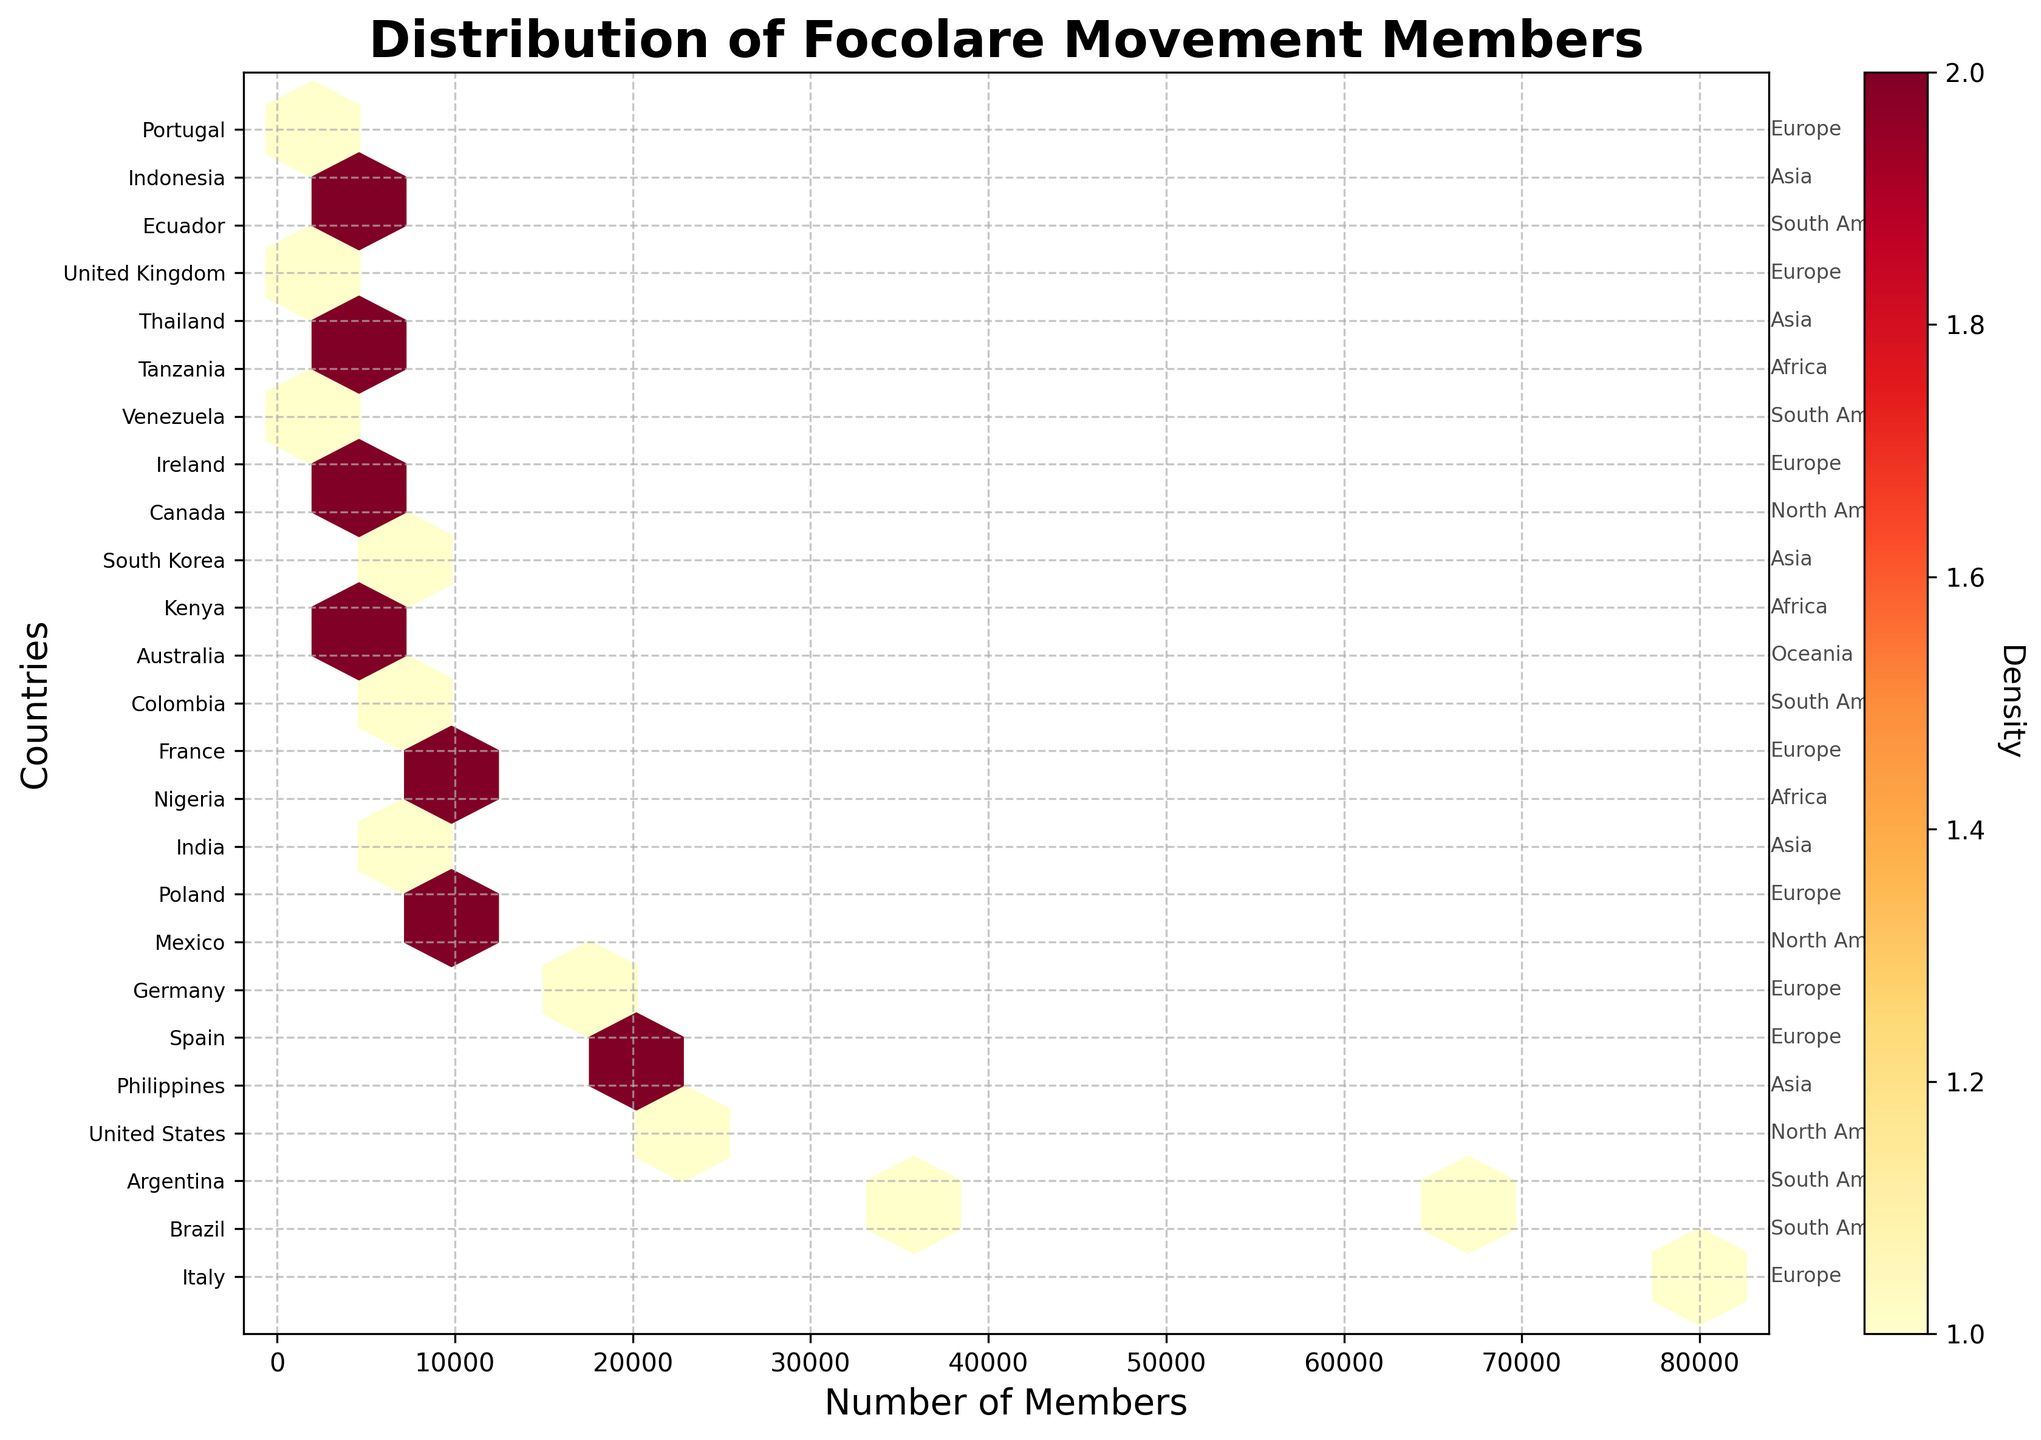What is the title of the plot? The title of the plot is typically located above the main figure and describes the context. In this case, it reads "Distribution of Focolare Movement Members."
Answer: Distribution of Focolare Movement Members How is the color used in the hexbin plot, and what does it represent? The color gradient in the hexbin plot ranges from lighter to darker shades of yellow and red. This color intensity represents the density of data points within each hexbin. Darker colors indicate higher densities of members in those countries.
Answer: Density of members Which country has the highest number of Focolare Movement members? The x-axis represents the number of members. The country with the highest number of members is positioned furthest to the right. Observing the labels, Italy has the highest number of members.
Answer: Italy How many countries have more than 20,000 members? By identifying countries with x-values greater than 20,000 and counting their corresponding labels, we can determine the number of such countries. These countries are Italy, Brazil, Argentina, the United States, and the Philippines. Therefore, there are 5 countries with more than 20,000 members.
Answer: 5 Which continent is Italy part of, as indicated in the plot? The plot annotates each country's continent next to the country labels. The annotation shows that Italy is part of Europe.
Answer: Europe Compare the number of members in South Korea and Australia. Which country has more members? South Korea and Australia are labeled on the y-axis. By checking their x-values (members), it can be seen that Australia (6,500 members) has more members compared to South Korea (5,500 members).
Answer: Australia How dense is the region with the highest member count in Africa? To determine density, we look at the color intensity of the hexbin where African countries lie. The region with the highest density in Africa corresponds to Nigeria with 8,000 members, indicating a medium to low density based on color shade.
Answer: Medium to low What is the sum of members in North American countries? The sum of members in North America can be calculated by adding the values for the United States (25,000), Mexico (12,000), and Canada (5,000). Summing them gives us 42,000 members.
Answer: 42,000 Are there any countries on the plot with exactly 10,000 members? If so, which one(s)? By looking at the x-axis for the value of 10,000 and corresponding y-labels, we find that Poland has exactly 10,000 members.
Answer: Poland What can be inferred about the spread of members across continents from the plot? By looking at the x-positions and colorings, Europe and South America have multiple countries with higher membership densities. Other continents like Africa and Oceania show fewer and lower density hexbins, indicating fewer members.
Answer: Higher in Europe and South America, fewer in Africa and Oceania 